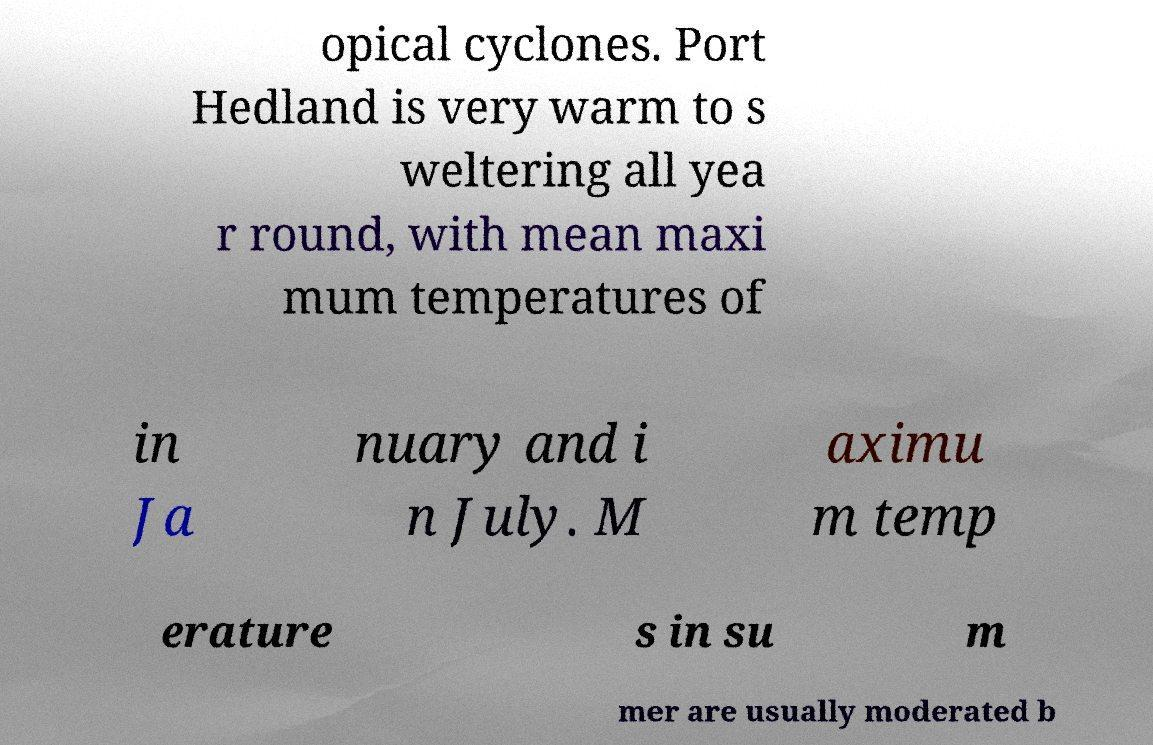What messages or text are displayed in this image? I need them in a readable, typed format. opical cyclones. Port Hedland is very warm to s weltering all yea r round, with mean maxi mum temperatures of in Ja nuary and i n July. M aximu m temp erature s in su m mer are usually moderated b 